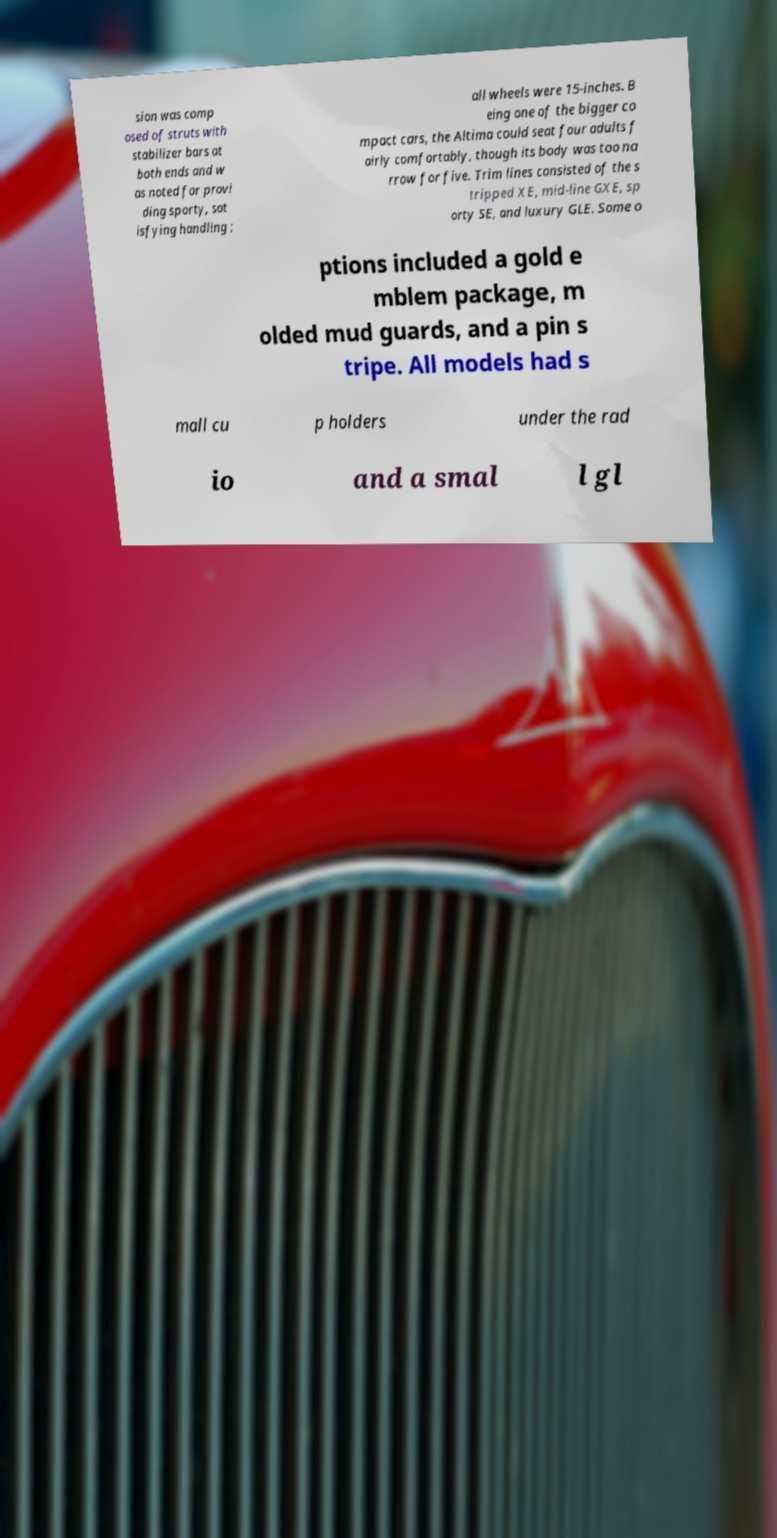For documentation purposes, I need the text within this image transcribed. Could you provide that? sion was comp osed of struts with stabilizer bars at both ends and w as noted for provi ding sporty, sat isfying handling ; all wheels were 15-inches. B eing one of the bigger co mpact cars, the Altima could seat four adults f airly comfortably, though its body was too na rrow for five. Trim lines consisted of the s tripped XE, mid-line GXE, sp orty SE, and luxury GLE. Some o ptions included a gold e mblem package, m olded mud guards, and a pin s tripe. All models had s mall cu p holders under the rad io and a smal l gl 